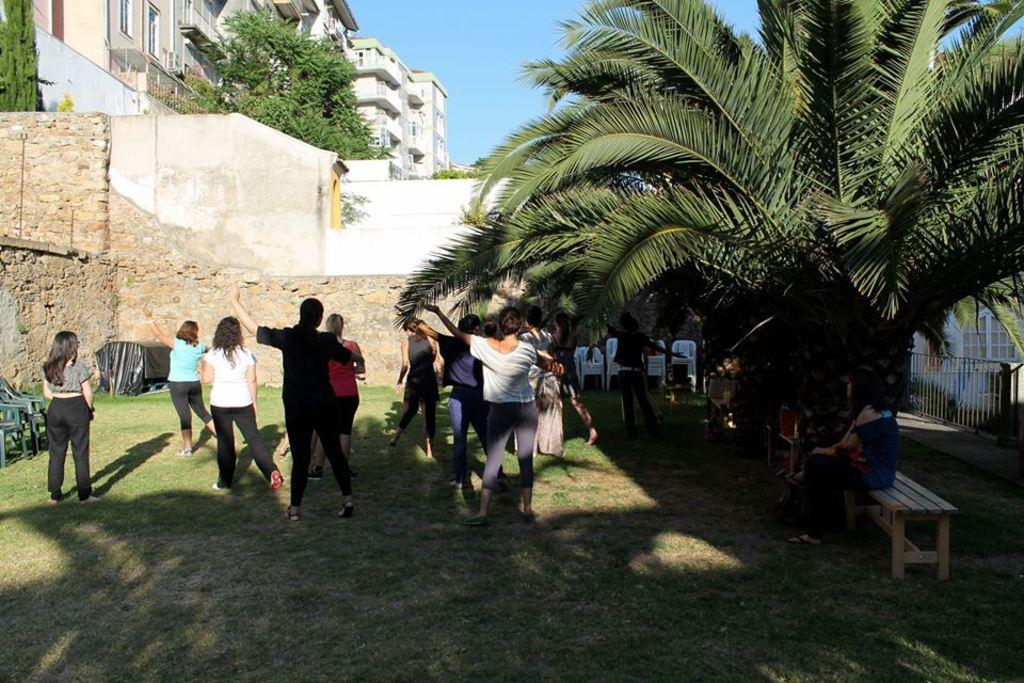In one or two sentences, can you explain what this image depicts? In the image we can see few persons were standing. In the background there is a sky,building,trees,wall,gate,chairs,grass and few persons were sitting on the bench. 